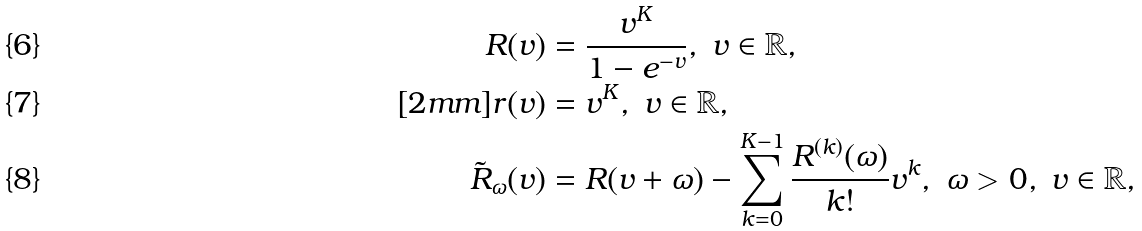Convert formula to latex. <formula><loc_0><loc_0><loc_500><loc_500>R ( v ) & = \frac { v ^ { K } } { 1 - e ^ { - v } } , \ v \in \mathbb { R } , \\ [ 2 m m ] r ( v ) & = v ^ { K } , \ v \in { \mathbb { R } } , \\ \tilde { R } _ { \omega } ( v ) & = R ( v + \omega ) - \sum _ { k = 0 } ^ { K - 1 } \frac { R ^ { ( k ) } ( \omega ) } { k ! } v ^ { k } , \ \omega > 0 , \ v \in { \mathbb { R } } ,</formula> 